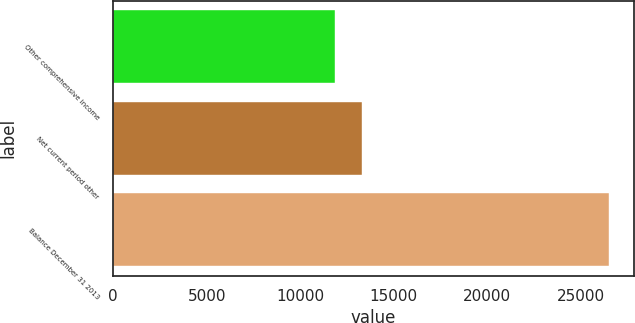<chart> <loc_0><loc_0><loc_500><loc_500><bar_chart><fcel>Other comprehensive income<fcel>Net current period other<fcel>Balance December 31 2013<nl><fcel>11838<fcel>13304.8<fcel>26506<nl></chart> 